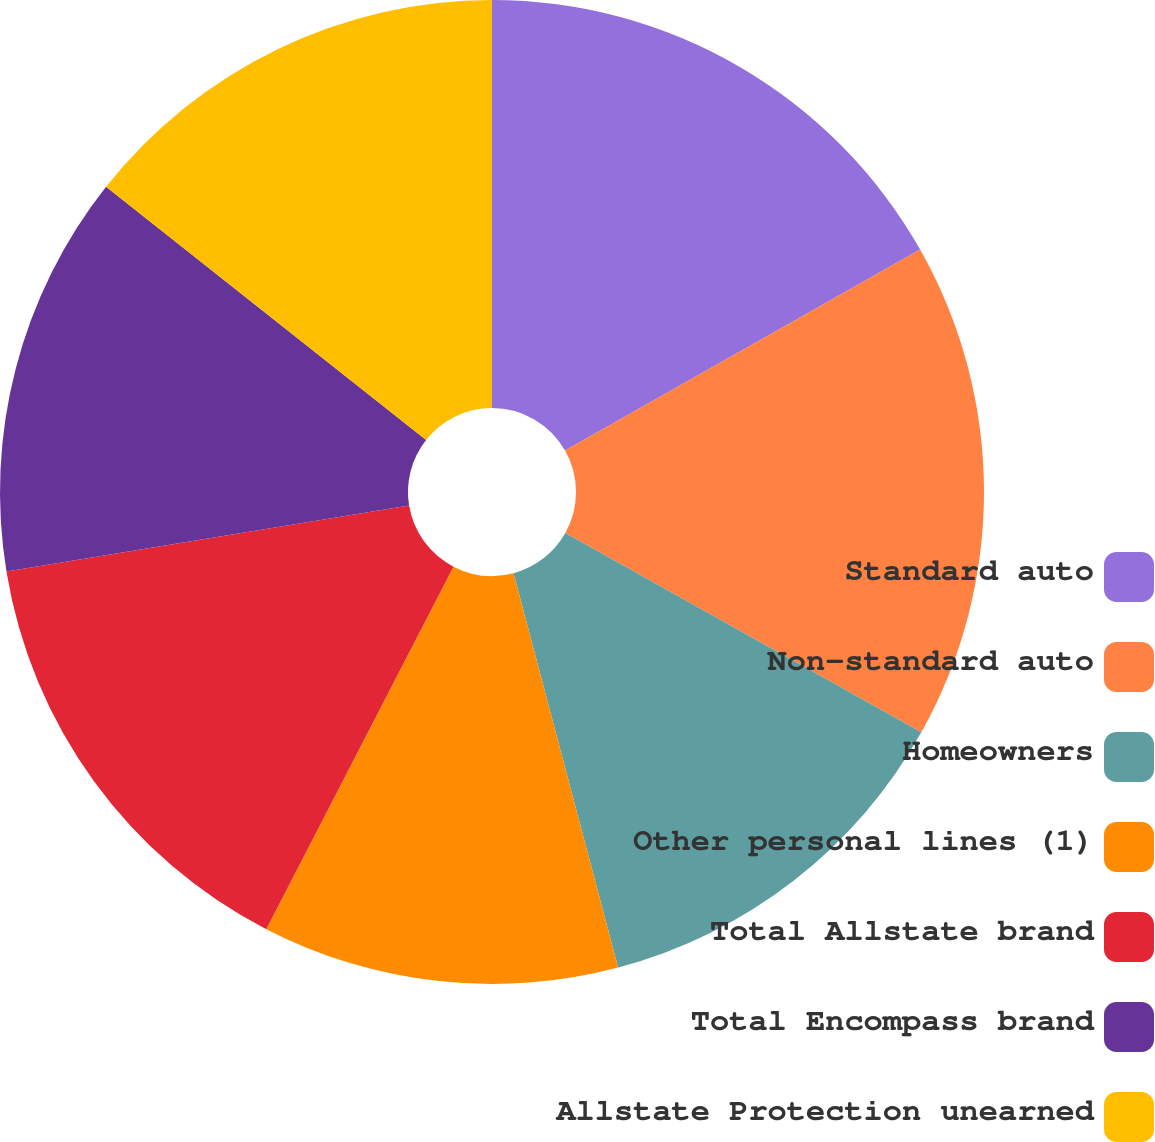<chart> <loc_0><loc_0><loc_500><loc_500><pie_chart><fcel>Standard auto<fcel>Non-standard auto<fcel>Homeowners<fcel>Other personal lines (1)<fcel>Total Allstate brand<fcel>Total Encompass brand<fcel>Allstate Protection unearned<nl><fcel>16.8%<fcel>16.32%<fcel>12.75%<fcel>11.71%<fcel>14.83%<fcel>13.23%<fcel>14.35%<nl></chart> 